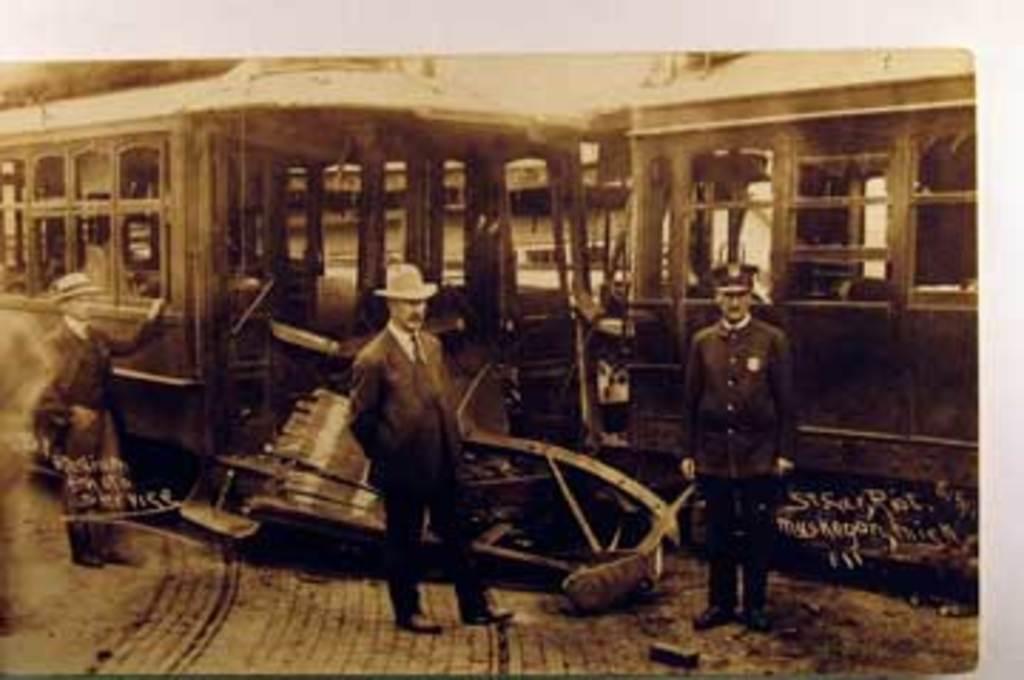Can you describe this image briefly? This is a black and white picture. In the foreground of the picture there are people. In the background there is a locomotive. 